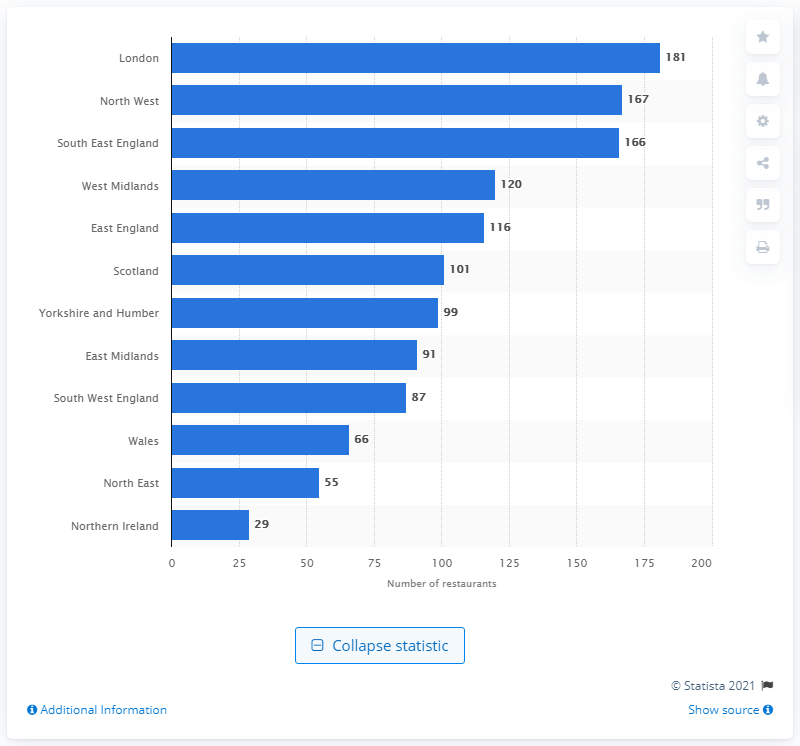Draw attention to some important aspects in this diagram. In 2017, there were 181 McDonald's restaurants located in London. 